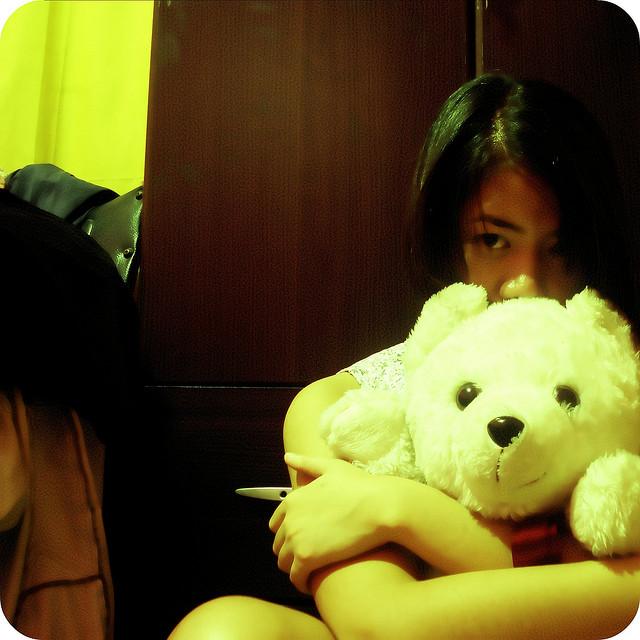What kind of stuffed animal is in the photo?
Answer briefly. Bear. What is the child holding?
Keep it brief. Teddy bear. Is that the child's left hand?
Short answer required. Yes. Are these fruit?
Write a very short answer. No. 